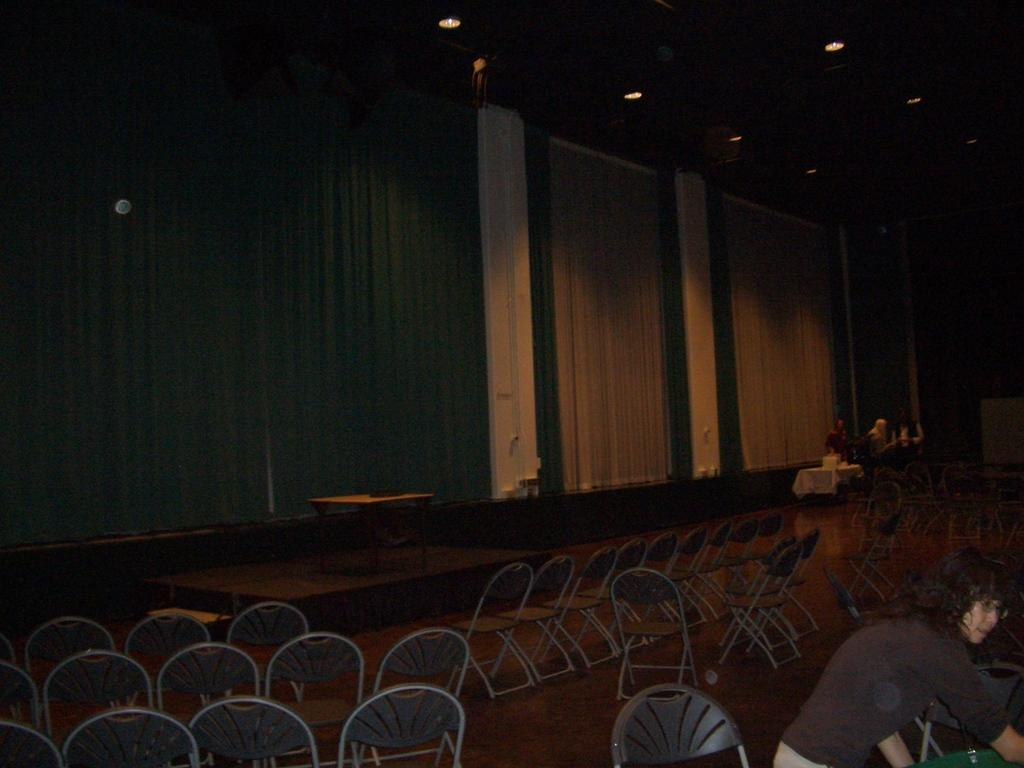What objects are present in the image that are typically used for sitting? There are empty chairs in the image. What piece of furniture is visible in the image that is commonly used for placing objects or eating? There is a table in the image. Where are the people in the image located? The people are standing in the right corner of the image. What type of reaction can be seen on the baby's face in the image? There is no baby present in the image, so it is not possible to determine any reaction on a baby's face. 